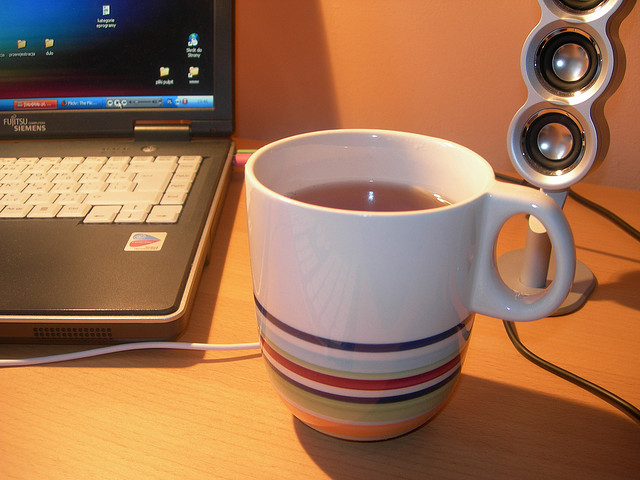Read and extract the text from this image. SIEMENS 